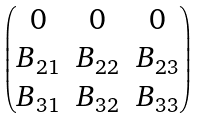<formula> <loc_0><loc_0><loc_500><loc_500>\begin{pmatrix} 0 & 0 & 0 \\ B _ { 2 1 } & B _ { 2 2 } & B _ { 2 3 } \\ B _ { 3 1 } & B _ { 3 2 } & B _ { 3 3 } \\ \end{pmatrix}</formula> 